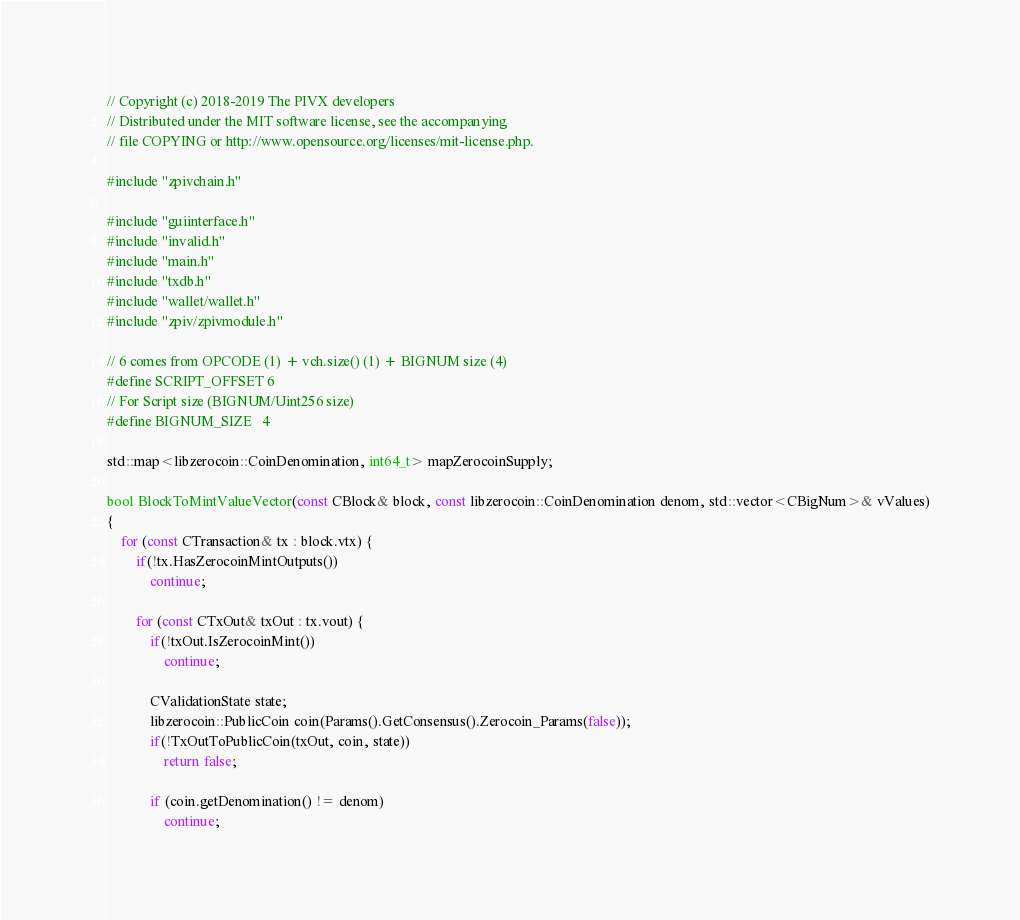Convert code to text. <code><loc_0><loc_0><loc_500><loc_500><_C++_>// Copyright (c) 2018-2019 The PIVX developers
// Distributed under the MIT software license, see the accompanying
// file COPYING or http://www.opensource.org/licenses/mit-license.php.

#include "zpivchain.h"

#include "guiinterface.h"
#include "invalid.h"
#include "main.h"
#include "txdb.h"
#include "wallet/wallet.h"
#include "zpiv/zpivmodule.h"

// 6 comes from OPCODE (1) + vch.size() (1) + BIGNUM size (4)
#define SCRIPT_OFFSET 6
// For Script size (BIGNUM/Uint256 size)
#define BIGNUM_SIZE   4

std::map<libzerocoin::CoinDenomination, int64_t> mapZerocoinSupply;

bool BlockToMintValueVector(const CBlock& block, const libzerocoin::CoinDenomination denom, std::vector<CBigNum>& vValues)
{
    for (const CTransaction& tx : block.vtx) {
        if(!tx.HasZerocoinMintOutputs())
            continue;

        for (const CTxOut& txOut : tx.vout) {
            if(!txOut.IsZerocoinMint())
                continue;

            CValidationState state;
            libzerocoin::PublicCoin coin(Params().GetConsensus().Zerocoin_Params(false));
            if(!TxOutToPublicCoin(txOut, coin, state))
                return false;

            if (coin.getDenomination() != denom)
                continue;
</code> 